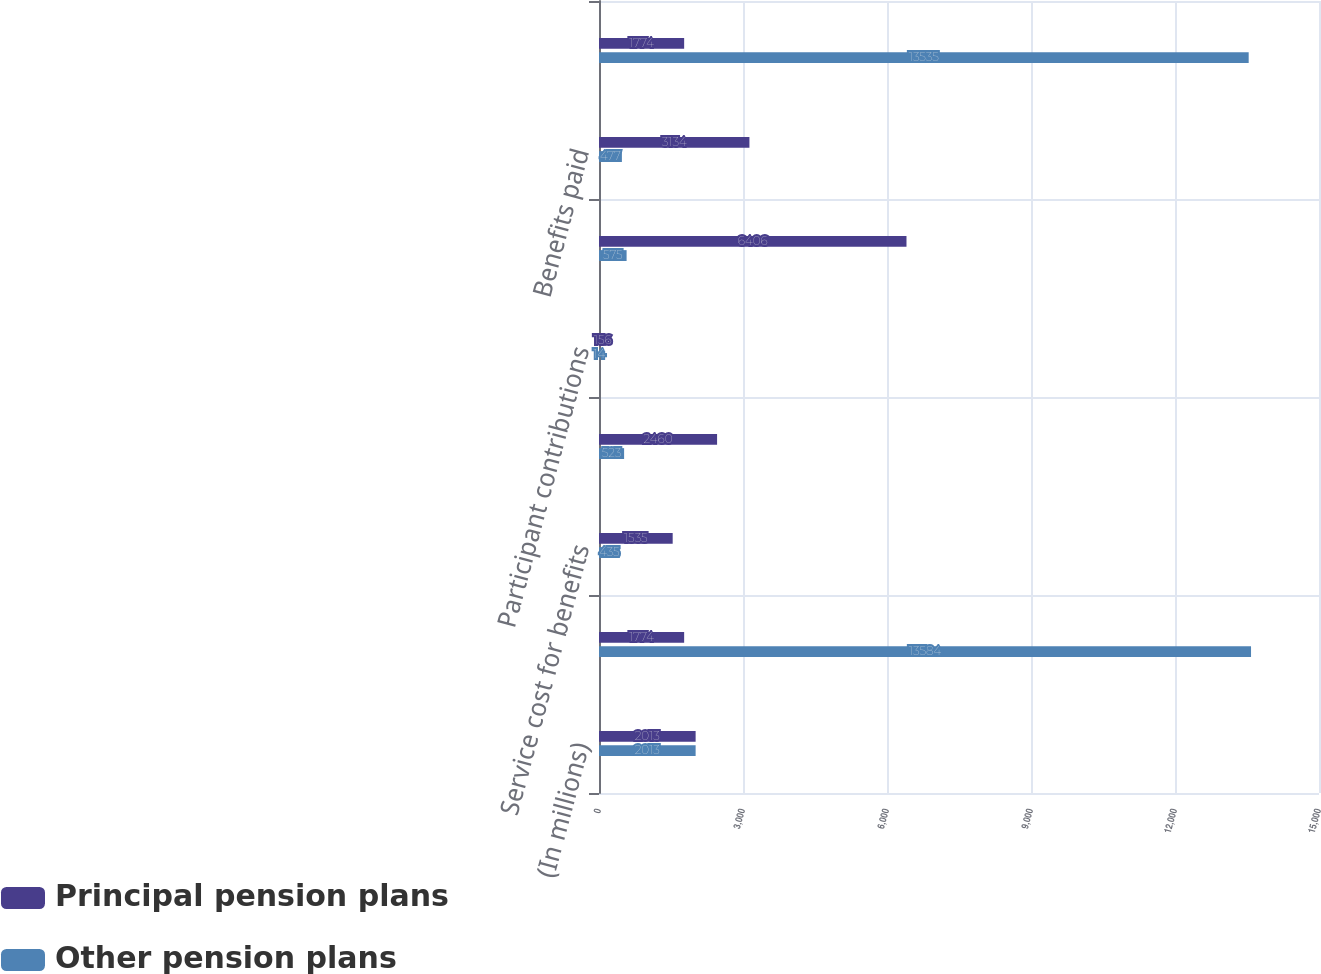Convert chart. <chart><loc_0><loc_0><loc_500><loc_500><stacked_bar_chart><ecel><fcel>(In millions)<fcel>Balance at January 1<fcel>Service cost for benefits<fcel>Interest cost on benefit<fcel>Participant contributions<fcel>Actuarial loss (gain) (a)<fcel>Benefits paid<fcel>Balance at December 31 (b)<nl><fcel>Principal pension plans<fcel>2013<fcel>1774<fcel>1535<fcel>2460<fcel>156<fcel>6406<fcel>3134<fcel>1774<nl><fcel>Other pension plans<fcel>2013<fcel>13584<fcel>435<fcel>523<fcel>14<fcel>575<fcel>477<fcel>13535<nl></chart> 